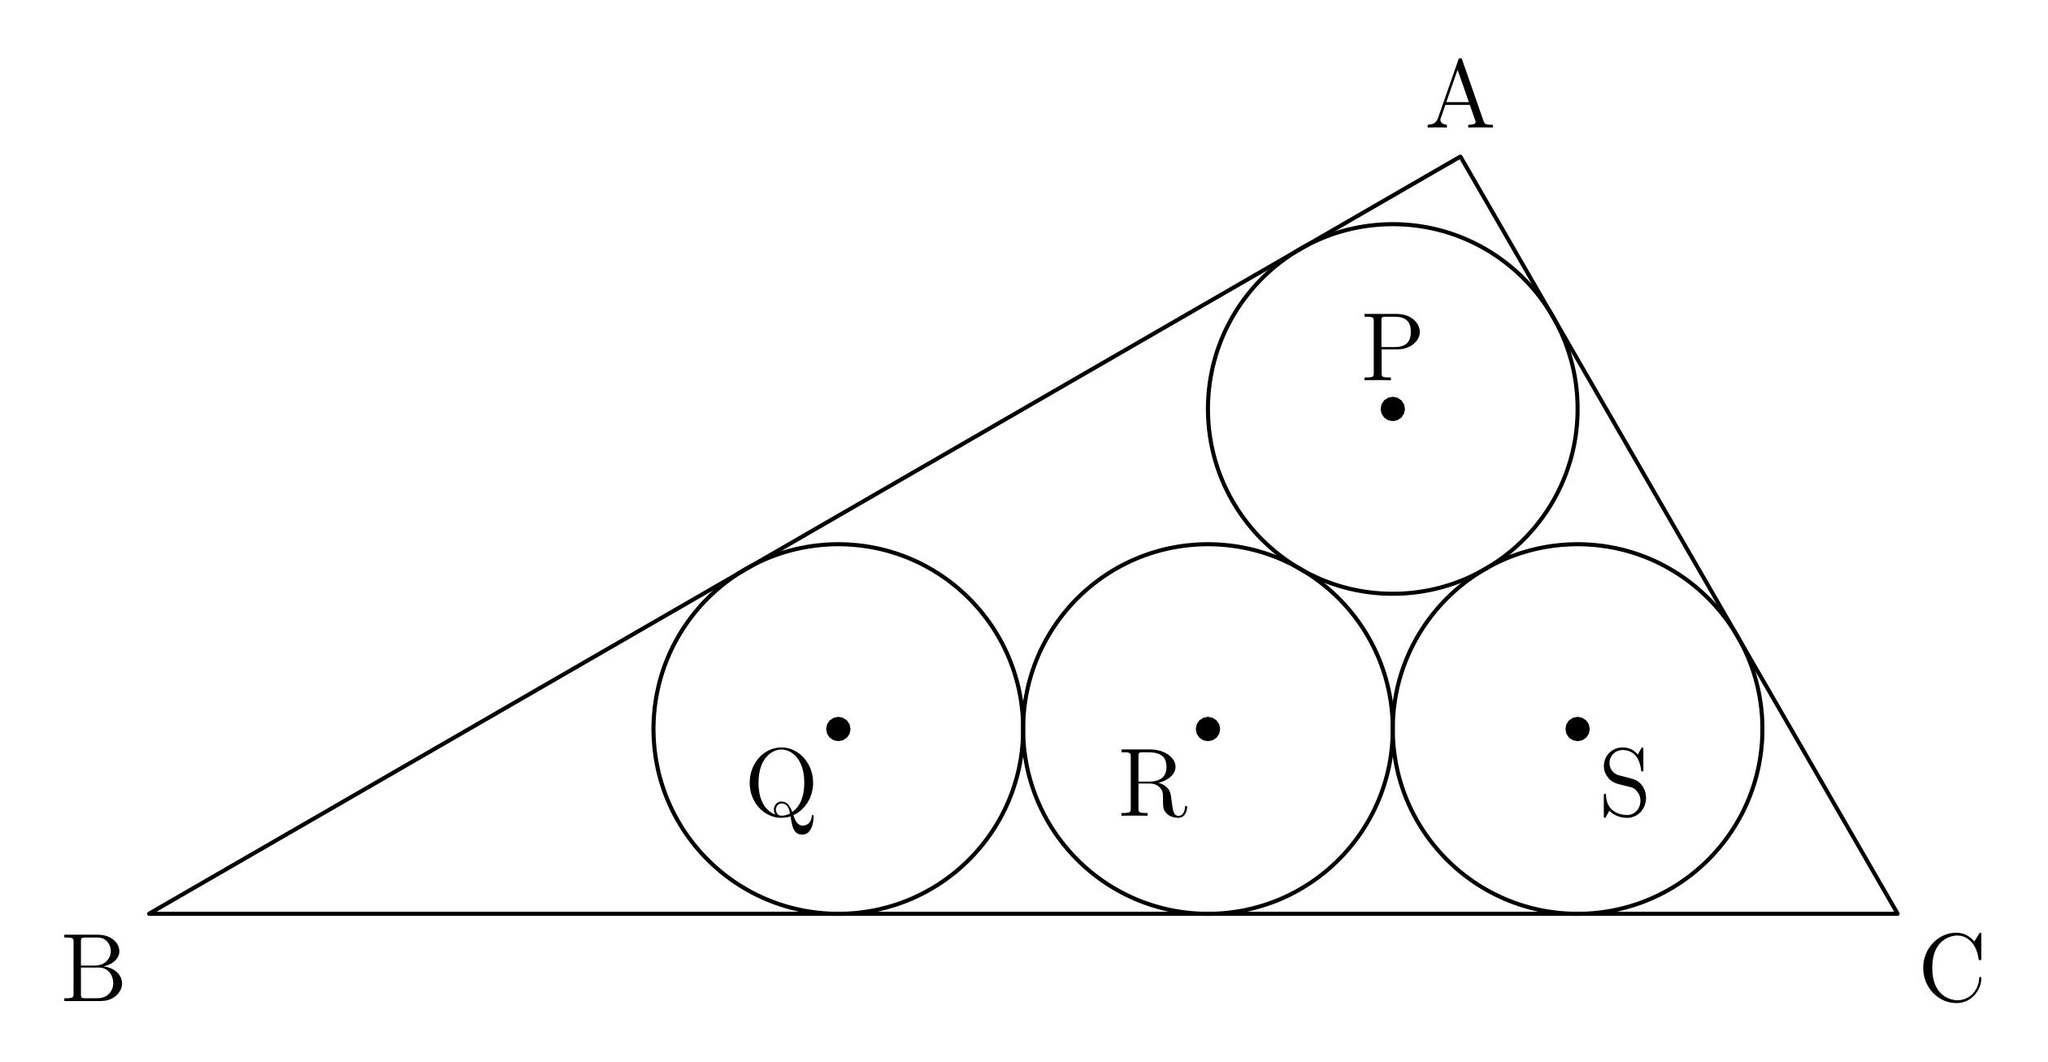What geometric properties of triangle ABC can we infer based on the arrangement of the circles? Given the circles are tangent to each triangle side and each other, triangle ABC likely has sides that are significantly longer than those of triangle PQS, allowing it to encompass all four circles. Additionally, the fact that four equal circles fit exactly within the triangle hints at specific angular relationships and possibly symmetry in ABC, suggesting that its shape and dimensions may adhere to particular geometric ratios. 